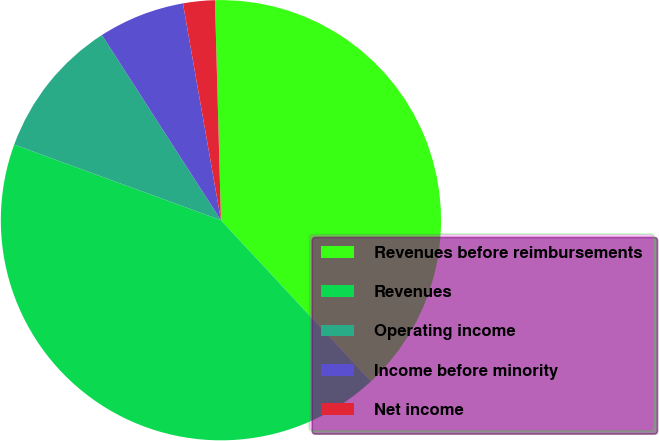Convert chart to OTSL. <chart><loc_0><loc_0><loc_500><loc_500><pie_chart><fcel>Revenues before reimbursements<fcel>Revenues<fcel>Operating income<fcel>Income before minority<fcel>Net income<nl><fcel>38.51%<fcel>42.51%<fcel>10.33%<fcel>6.33%<fcel>2.33%<nl></chart> 